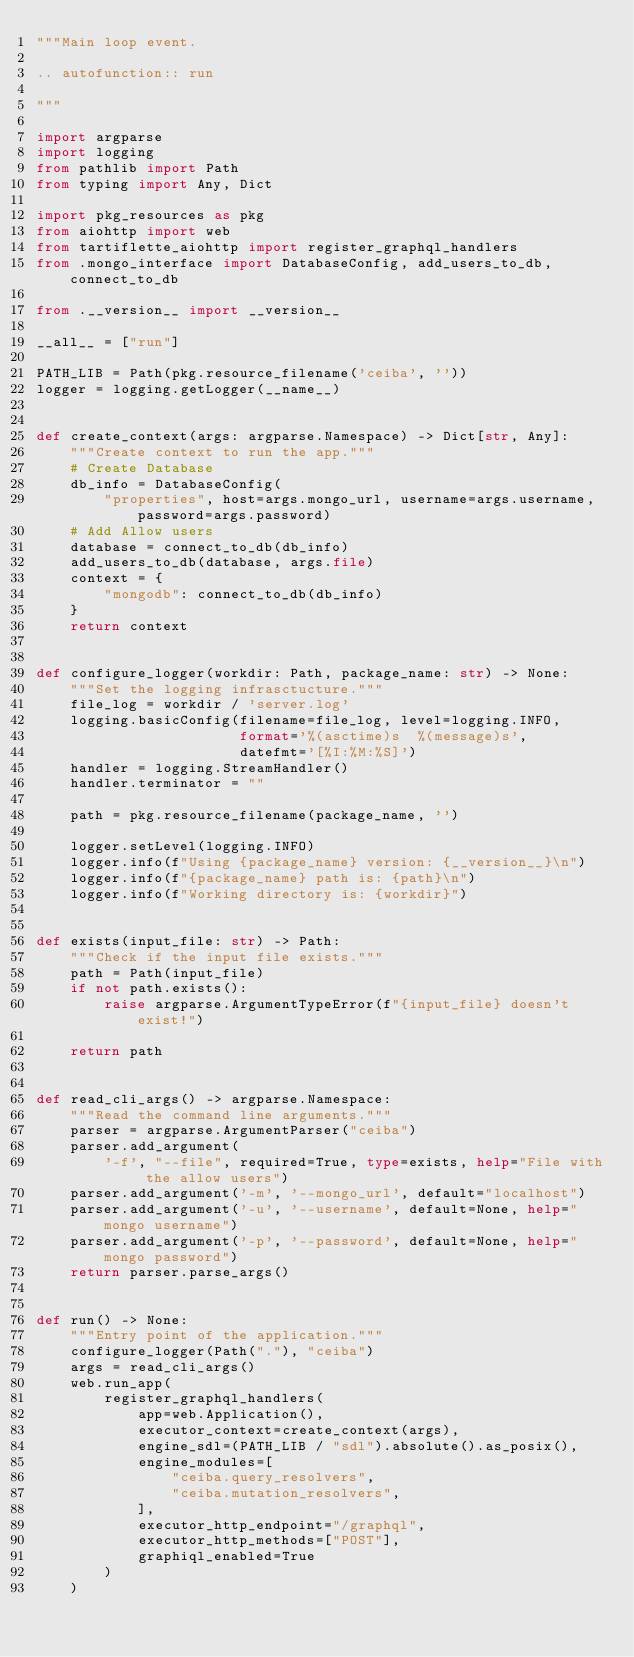Convert code to text. <code><loc_0><loc_0><loc_500><loc_500><_Python_>"""Main loop event.

.. autofunction:: run

"""

import argparse
import logging
from pathlib import Path
from typing import Any, Dict

import pkg_resources as pkg
from aiohttp import web
from tartiflette_aiohttp import register_graphql_handlers
from .mongo_interface import DatabaseConfig, add_users_to_db, connect_to_db

from .__version__ import __version__

__all__ = ["run"]

PATH_LIB = Path(pkg.resource_filename('ceiba', ''))
logger = logging.getLogger(__name__)


def create_context(args: argparse.Namespace) -> Dict[str, Any]:
    """Create context to run the app."""
    # Create Database
    db_info = DatabaseConfig(
        "properties", host=args.mongo_url, username=args.username, password=args.password)
    # Add Allow users
    database = connect_to_db(db_info)
    add_users_to_db(database, args.file)
    context = {
        "mongodb": connect_to_db(db_info)
    }
    return context


def configure_logger(workdir: Path, package_name: str) -> None:
    """Set the logging infrasctucture."""
    file_log = workdir / 'server.log'
    logging.basicConfig(filename=file_log, level=logging.INFO,
                        format='%(asctime)s  %(message)s',
                        datefmt='[%I:%M:%S]')
    handler = logging.StreamHandler()
    handler.terminator = ""

    path = pkg.resource_filename(package_name, '')

    logger.setLevel(logging.INFO)
    logger.info(f"Using {package_name} version: {__version__}\n")
    logger.info(f"{package_name} path is: {path}\n")
    logger.info(f"Working directory is: {workdir}")


def exists(input_file: str) -> Path:
    """Check if the input file exists."""
    path = Path(input_file)
    if not path.exists():
        raise argparse.ArgumentTypeError(f"{input_file} doesn't exist!")

    return path


def read_cli_args() -> argparse.Namespace:
    """Read the command line arguments."""
    parser = argparse.ArgumentParser("ceiba")
    parser.add_argument(
        '-f', "--file", required=True, type=exists, help="File with the allow users")
    parser.add_argument('-m', '--mongo_url', default="localhost")
    parser.add_argument('-u', '--username', default=None, help="mongo username")
    parser.add_argument('-p', '--password', default=None, help="mongo password")
    return parser.parse_args()


def run() -> None:
    """Entry point of the application."""
    configure_logger(Path("."), "ceiba")
    args = read_cli_args()
    web.run_app(
        register_graphql_handlers(
            app=web.Application(),
            executor_context=create_context(args),
            engine_sdl=(PATH_LIB / "sdl").absolute().as_posix(),
            engine_modules=[
                "ceiba.query_resolvers",
                "ceiba.mutation_resolvers",
            ],
            executor_http_endpoint="/graphql",
            executor_http_methods=["POST"],
            graphiql_enabled=True
        )
    )
</code> 